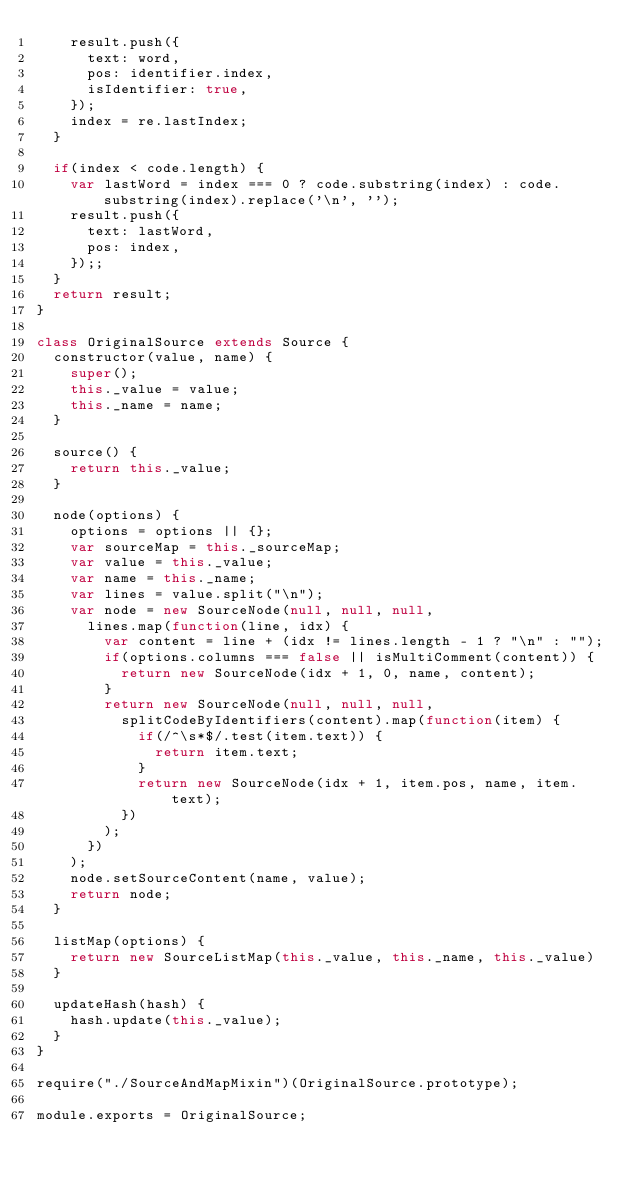Convert code to text. <code><loc_0><loc_0><loc_500><loc_500><_JavaScript_>		result.push({
			text: word,
			pos: identifier.index,
			isIdentifier: true,
		});
		index = re.lastIndex;
	}

	if(index < code.length) {
		var lastWord = index === 0 ? code.substring(index) : code.substring(index).replace('\n', '');
		result.push({
			text: lastWord,
			pos: index,
		});;
	}
	return result;
}

class OriginalSource extends Source {
	constructor(value, name) {
		super();
		this._value = value;
		this._name = name;
	}

	source() {
		return this._value;
	}

	node(options) {
		options = options || {};
		var sourceMap = this._sourceMap;
		var value = this._value;
		var name = this._name;
		var lines = value.split("\n");
		var node = new SourceNode(null, null, null,
			lines.map(function(line, idx) {
				var content = line + (idx != lines.length - 1 ? "\n" : "");
				if(options.columns === false || isMultiComment(content)) {
					return new SourceNode(idx + 1, 0, name, content);
				}
				return new SourceNode(null, null, null,
					splitCodeByIdentifiers(content).map(function(item) {
						if(/^\s*$/.test(item.text)) {
							return item.text;
						}
						return new SourceNode(idx + 1, item.pos, name, item.text);
					})
				);
			})
		);
		node.setSourceContent(name, value);
		return node;
	}

	listMap(options) {
		return new SourceListMap(this._value, this._name, this._value)
	}

	updateHash(hash) {
		hash.update(this._value);
	}
}

require("./SourceAndMapMixin")(OriginalSource.prototype);

module.exports = OriginalSource;
</code> 